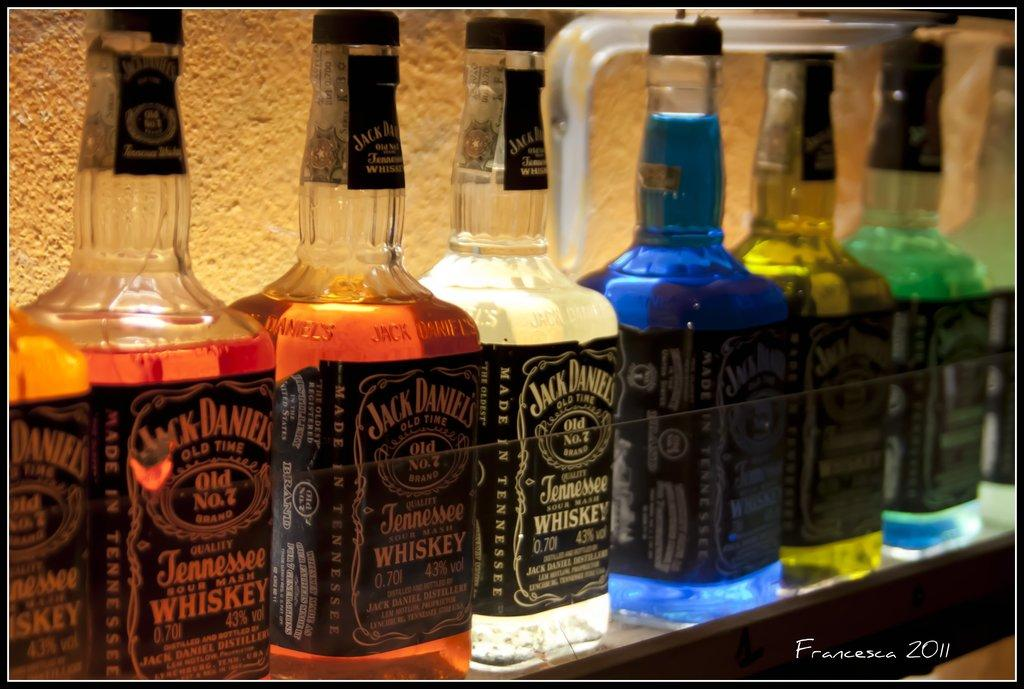<image>
Create a compact narrative representing the image presented. A line of Jack Daniels bottles with various colored liquids being lit from behind. 